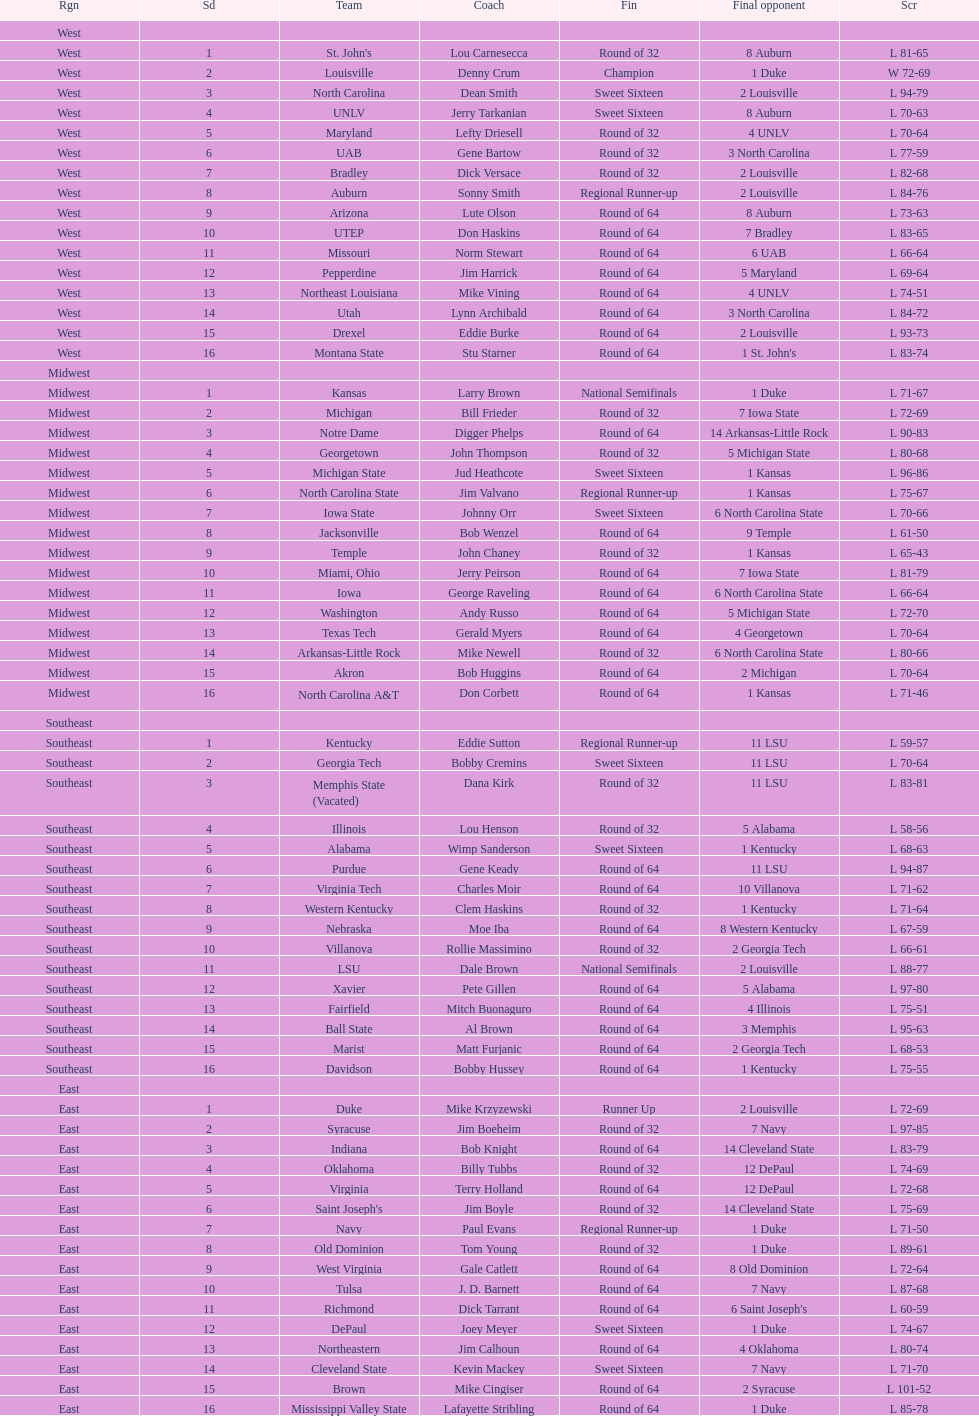Which team went finished later in the tournament, st. john's or north carolina a&t? North Carolina A&T. 